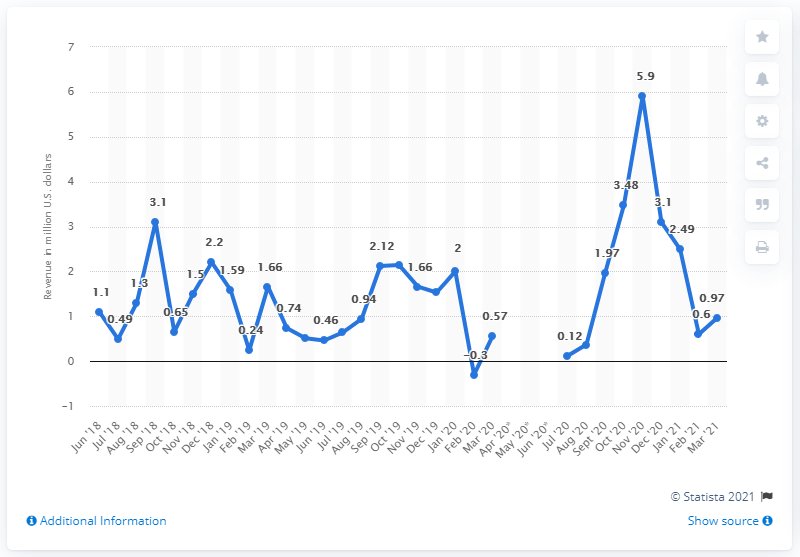Identify some key points in this picture. In March 2021, Delaware generated approximately $0.97 million in revenue from sports betting. 